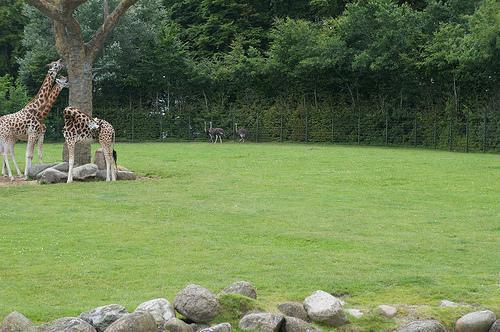How many giraffes are there?
Give a very brief answer. 3. How many giraffes are in the photo?
Give a very brief answer. 3. 